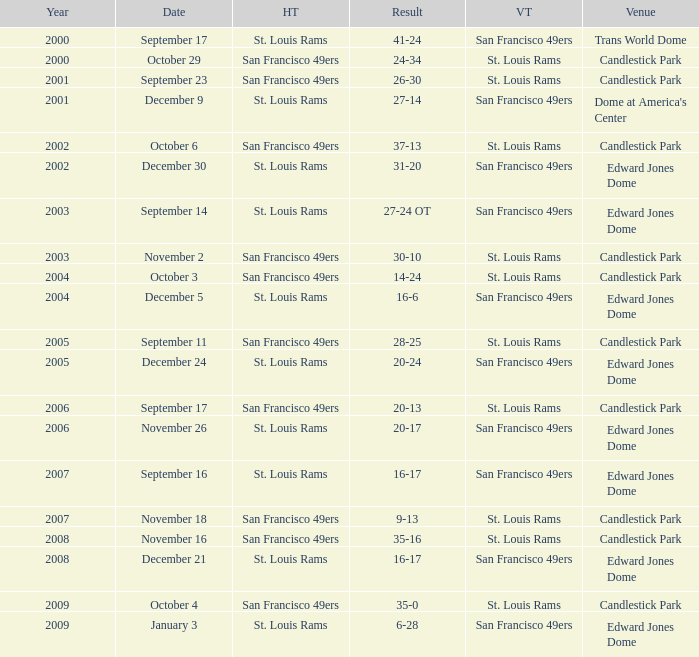What is the Venue of the 2009 St. Louis Rams Home game? Edward Jones Dome. 